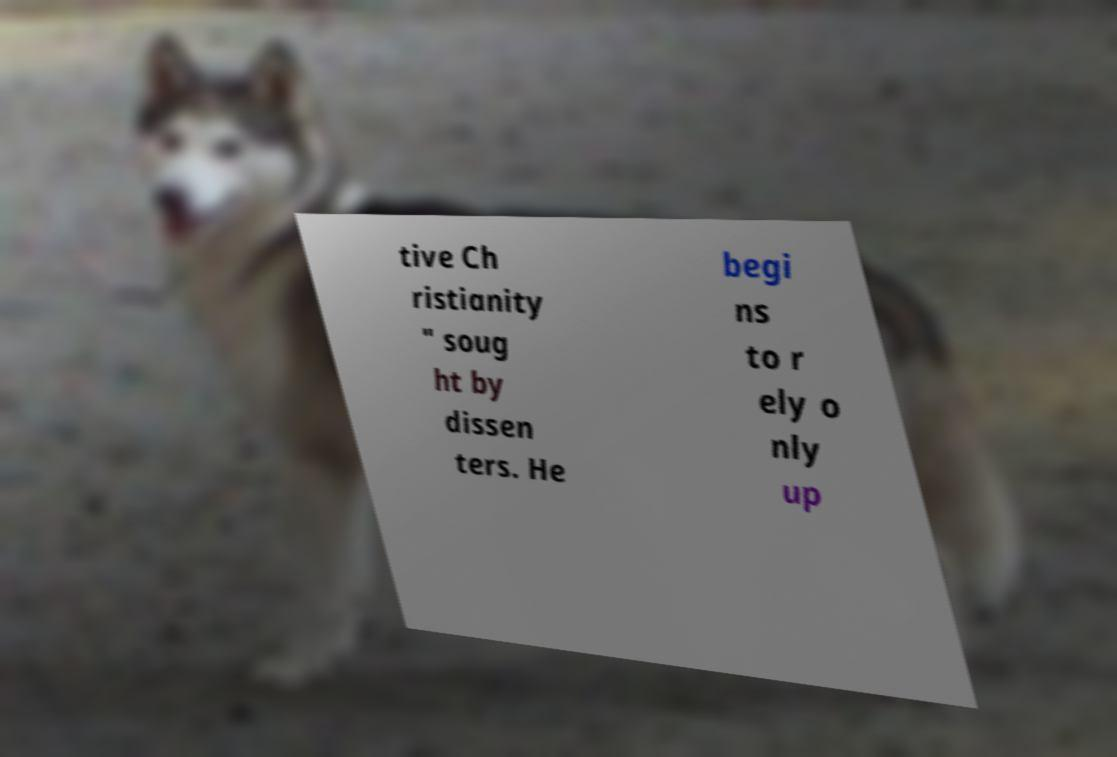There's text embedded in this image that I need extracted. Can you transcribe it verbatim? tive Ch ristianity " soug ht by dissen ters. He begi ns to r ely o nly up 